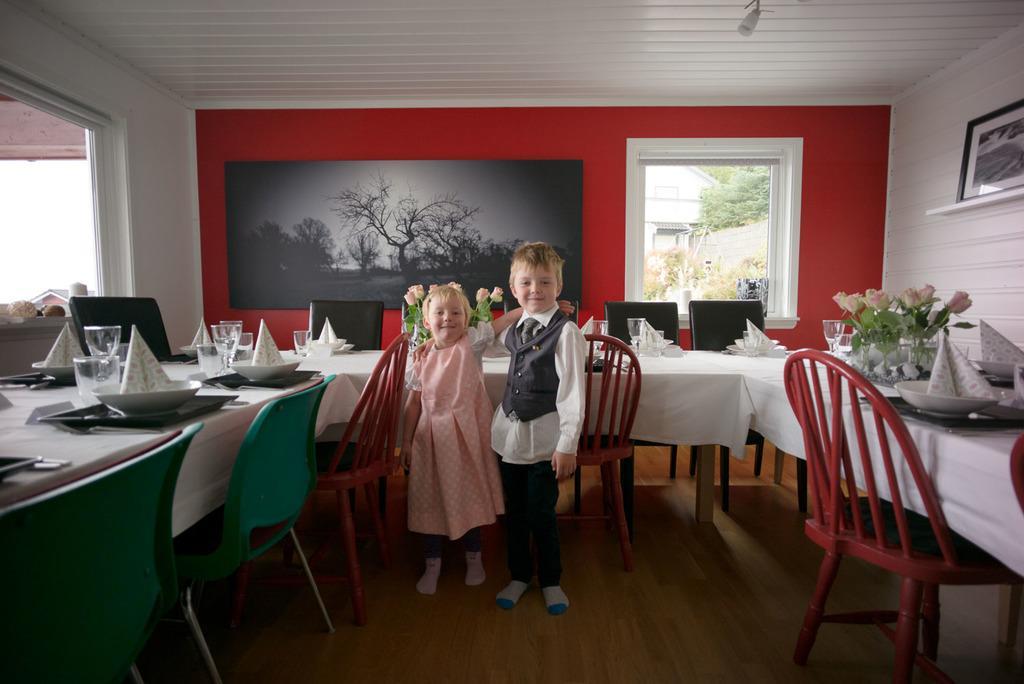Please provide a concise description of this image. In this image there is a boy and a girl standing on a wooden floor, around them there are chairs, tables, on that tables there are glasses, bowls and flower vases, in the background there is wall for that wall there are windows, photo frames, at the top there is a ceiling. 